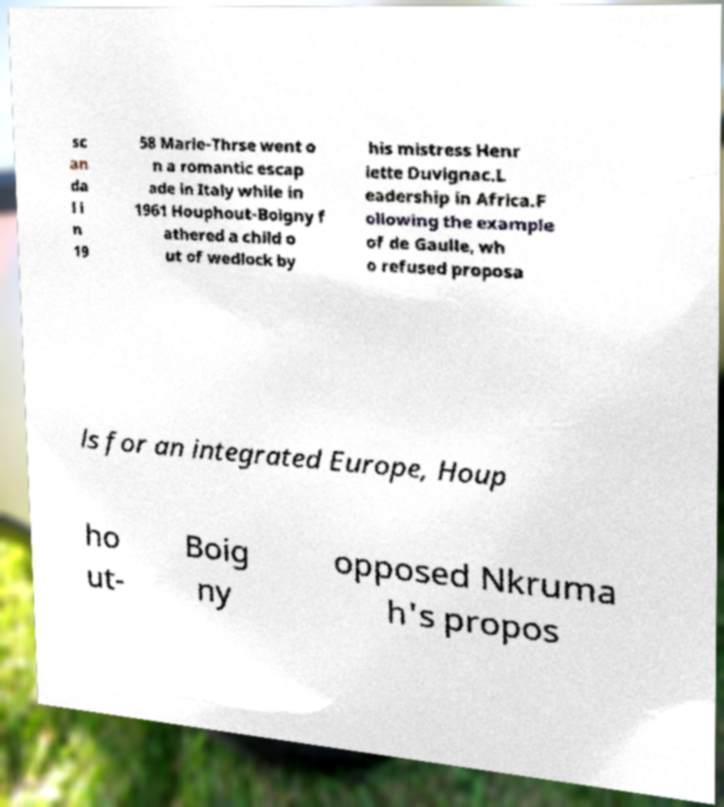Can you read and provide the text displayed in the image?This photo seems to have some interesting text. Can you extract and type it out for me? sc an da l i n 19 58 Marie-Thrse went o n a romantic escap ade in Italy while in 1961 Houphout-Boigny f athered a child o ut of wedlock by his mistress Henr iette Duvignac.L eadership in Africa.F ollowing the example of de Gaulle, wh o refused proposa ls for an integrated Europe, Houp ho ut- Boig ny opposed Nkruma h's propos 